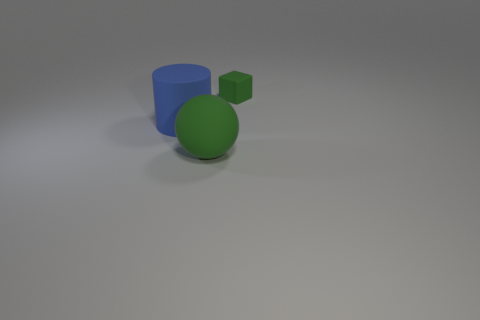Add 2 large blue rubber things. How many objects exist? 5 Subtract all spheres. How many objects are left? 2 Subtract all large green balls. Subtract all big blue rubber cylinders. How many objects are left? 1 Add 2 large spheres. How many large spheres are left? 3 Add 2 cylinders. How many cylinders exist? 3 Subtract 0 purple balls. How many objects are left? 3 